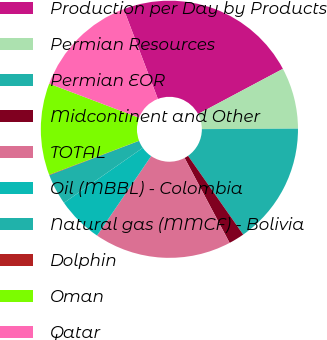Convert chart to OTSL. <chart><loc_0><loc_0><loc_500><loc_500><pie_chart><fcel>Production per Day by Products<fcel>Permian Resources<fcel>Permian EOR<fcel>Midcontinent and Other<fcel>TOTAL<fcel>Oil (MBBL) - Colombia<fcel>Natural gas (MMCF) - Bolivia<fcel>Dolphin<fcel>Oman<fcel>Qatar<nl><fcel>23.0%<fcel>7.71%<fcel>15.35%<fcel>1.97%<fcel>17.27%<fcel>5.79%<fcel>3.88%<fcel>0.06%<fcel>11.53%<fcel>13.44%<nl></chart> 